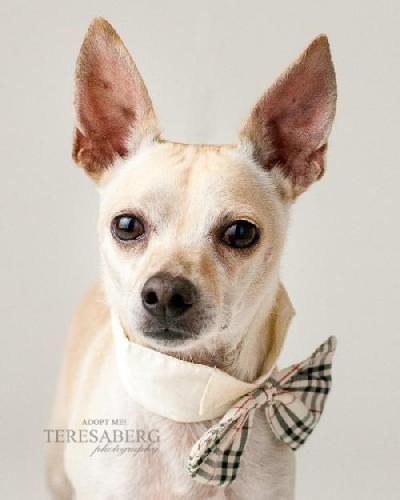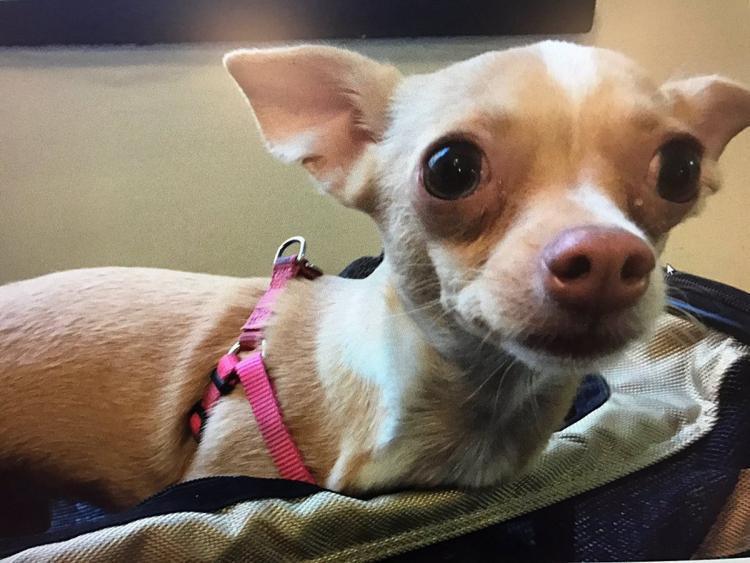The first image is the image on the left, the second image is the image on the right. Analyze the images presented: Is the assertion "An image shows two small chihuahuas, one on each side of a male person facing the camera." valid? Answer yes or no. No. The first image is the image on the left, the second image is the image on the right. Analyze the images presented: Is the assertion "The right image contains exactly two dogs." valid? Answer yes or no. No. 